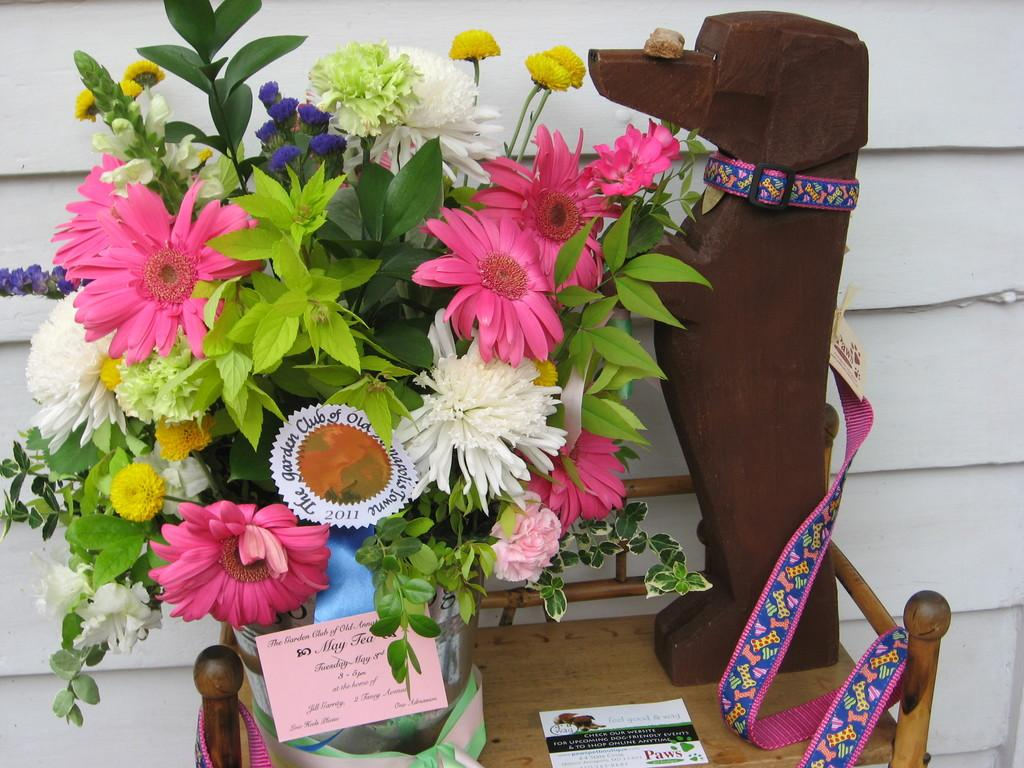What is placed on the table in the image? There are flowers on a table in the image. What is located beside the flowers on the table? There is a dog's structure made from wood beside the flowers. What color are the eyes of the dog's structure made from wood? There are no eyes present on the dog's structure made from wood in the image, as it is a wooden representation and not a real dog. 